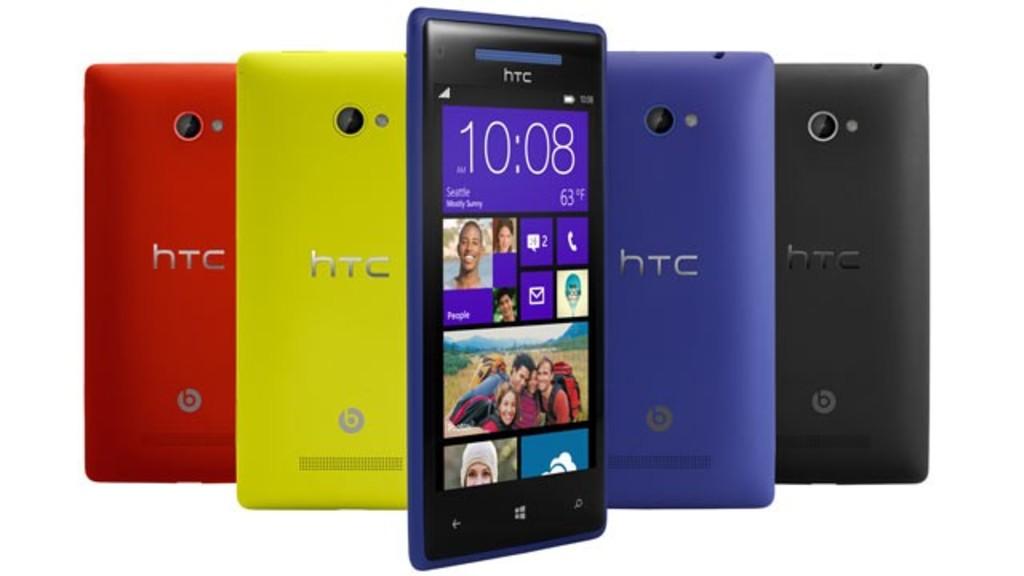What time is on the phone?
Offer a terse response. 10:08. What kind of phone?
Keep it short and to the point. Htc. 